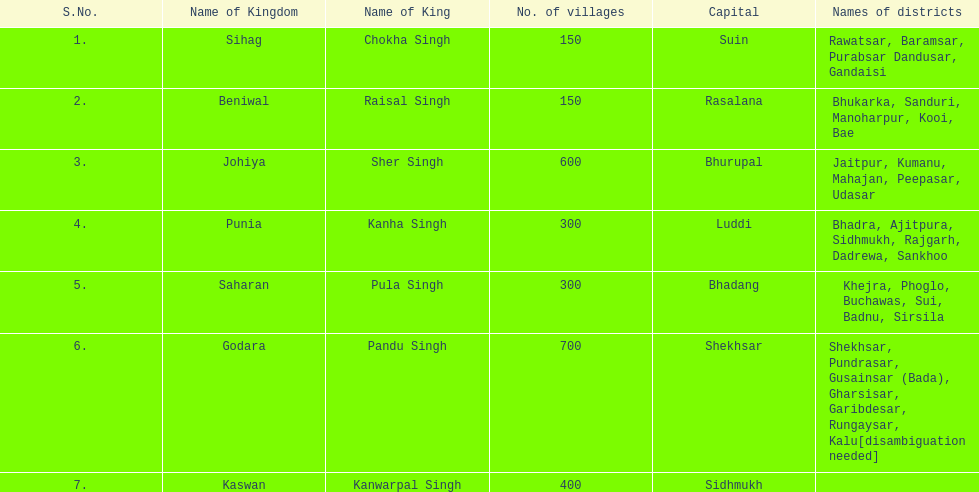What was the total number of districts within the state of godara? 7. 